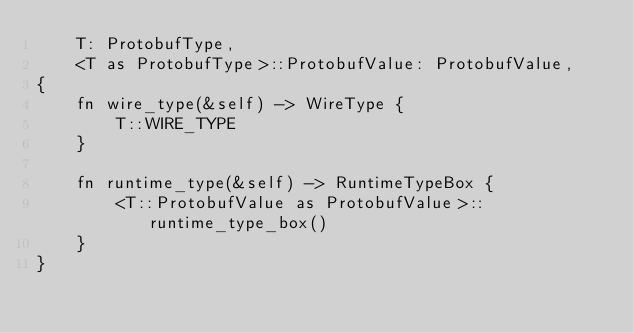Convert code to text. <code><loc_0><loc_0><loc_500><loc_500><_Rust_>    T: ProtobufType,
    <T as ProtobufType>::ProtobufValue: ProtobufValue,
{
    fn wire_type(&self) -> WireType {
        T::WIRE_TYPE
    }

    fn runtime_type(&self) -> RuntimeTypeBox {
        <T::ProtobufValue as ProtobufValue>::runtime_type_box()
    }
}
</code> 